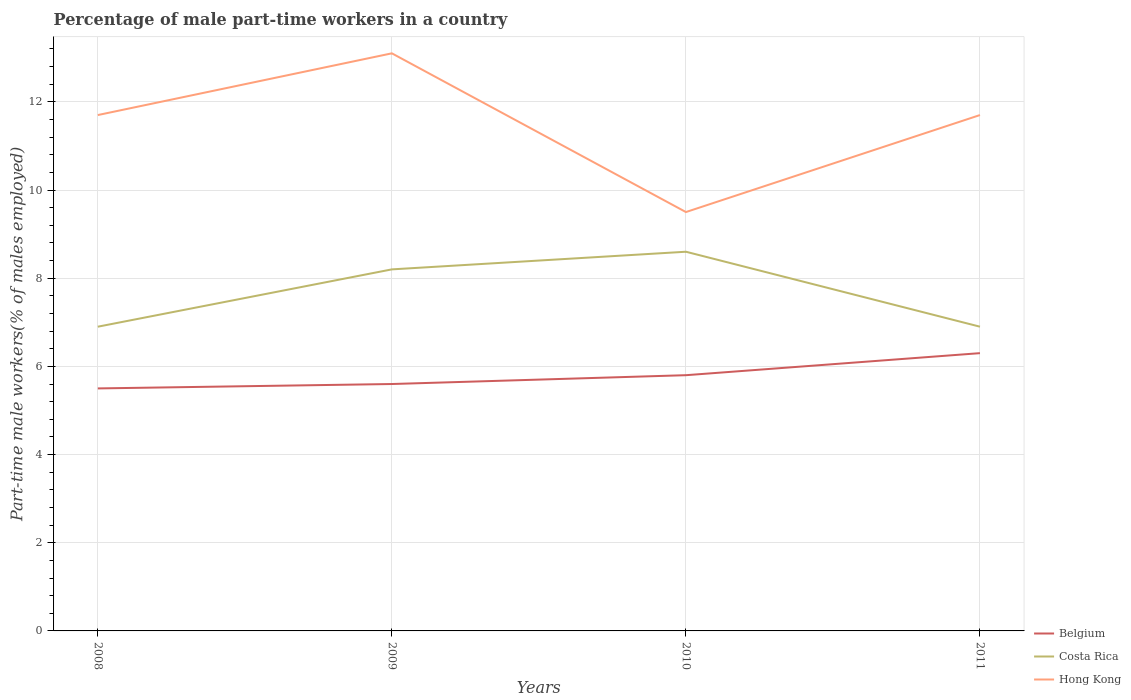How many different coloured lines are there?
Keep it short and to the point. 3. Across all years, what is the maximum percentage of male part-time workers in Hong Kong?
Give a very brief answer. 9.5. What is the total percentage of male part-time workers in Costa Rica in the graph?
Provide a succinct answer. -1.3. What is the difference between the highest and the second highest percentage of male part-time workers in Belgium?
Offer a terse response. 0.8. What is the difference between the highest and the lowest percentage of male part-time workers in Costa Rica?
Make the answer very short. 2. How many lines are there?
Keep it short and to the point. 3. Are the values on the major ticks of Y-axis written in scientific E-notation?
Provide a succinct answer. No. Where does the legend appear in the graph?
Your answer should be very brief. Bottom right. What is the title of the graph?
Your answer should be compact. Percentage of male part-time workers in a country. What is the label or title of the X-axis?
Your answer should be compact. Years. What is the label or title of the Y-axis?
Keep it short and to the point. Part-time male workers(% of males employed). What is the Part-time male workers(% of males employed) of Belgium in 2008?
Give a very brief answer. 5.5. What is the Part-time male workers(% of males employed) in Costa Rica in 2008?
Give a very brief answer. 6.9. What is the Part-time male workers(% of males employed) in Hong Kong in 2008?
Provide a short and direct response. 11.7. What is the Part-time male workers(% of males employed) of Belgium in 2009?
Provide a succinct answer. 5.6. What is the Part-time male workers(% of males employed) in Costa Rica in 2009?
Give a very brief answer. 8.2. What is the Part-time male workers(% of males employed) of Hong Kong in 2009?
Ensure brevity in your answer.  13.1. What is the Part-time male workers(% of males employed) in Belgium in 2010?
Your answer should be very brief. 5.8. What is the Part-time male workers(% of males employed) in Costa Rica in 2010?
Offer a very short reply. 8.6. What is the Part-time male workers(% of males employed) in Hong Kong in 2010?
Ensure brevity in your answer.  9.5. What is the Part-time male workers(% of males employed) of Belgium in 2011?
Make the answer very short. 6.3. What is the Part-time male workers(% of males employed) of Costa Rica in 2011?
Ensure brevity in your answer.  6.9. What is the Part-time male workers(% of males employed) of Hong Kong in 2011?
Your answer should be compact. 11.7. Across all years, what is the maximum Part-time male workers(% of males employed) of Belgium?
Offer a terse response. 6.3. Across all years, what is the maximum Part-time male workers(% of males employed) in Costa Rica?
Provide a succinct answer. 8.6. Across all years, what is the maximum Part-time male workers(% of males employed) in Hong Kong?
Your answer should be very brief. 13.1. Across all years, what is the minimum Part-time male workers(% of males employed) in Belgium?
Your answer should be very brief. 5.5. Across all years, what is the minimum Part-time male workers(% of males employed) of Costa Rica?
Offer a terse response. 6.9. Across all years, what is the minimum Part-time male workers(% of males employed) of Hong Kong?
Provide a short and direct response. 9.5. What is the total Part-time male workers(% of males employed) in Belgium in the graph?
Your response must be concise. 23.2. What is the total Part-time male workers(% of males employed) in Costa Rica in the graph?
Ensure brevity in your answer.  30.6. What is the total Part-time male workers(% of males employed) of Hong Kong in the graph?
Ensure brevity in your answer.  46. What is the difference between the Part-time male workers(% of males employed) in Costa Rica in 2008 and that in 2010?
Give a very brief answer. -1.7. What is the difference between the Part-time male workers(% of males employed) of Hong Kong in 2008 and that in 2010?
Offer a very short reply. 2.2. What is the difference between the Part-time male workers(% of males employed) in Belgium in 2008 and that in 2011?
Your answer should be very brief. -0.8. What is the difference between the Part-time male workers(% of males employed) in Costa Rica in 2008 and that in 2011?
Offer a very short reply. 0. What is the difference between the Part-time male workers(% of males employed) in Hong Kong in 2008 and that in 2011?
Ensure brevity in your answer.  0. What is the difference between the Part-time male workers(% of males employed) in Costa Rica in 2009 and that in 2010?
Keep it short and to the point. -0.4. What is the difference between the Part-time male workers(% of males employed) of Hong Kong in 2009 and that in 2010?
Provide a short and direct response. 3.6. What is the difference between the Part-time male workers(% of males employed) of Belgium in 2009 and that in 2011?
Your response must be concise. -0.7. What is the difference between the Part-time male workers(% of males employed) of Costa Rica in 2009 and that in 2011?
Offer a terse response. 1.3. What is the difference between the Part-time male workers(% of males employed) in Hong Kong in 2009 and that in 2011?
Make the answer very short. 1.4. What is the difference between the Part-time male workers(% of males employed) in Costa Rica in 2010 and that in 2011?
Make the answer very short. 1.7. What is the difference between the Part-time male workers(% of males employed) in Hong Kong in 2010 and that in 2011?
Provide a short and direct response. -2.2. What is the difference between the Part-time male workers(% of males employed) in Belgium in 2008 and the Part-time male workers(% of males employed) in Costa Rica in 2010?
Ensure brevity in your answer.  -3.1. What is the difference between the Part-time male workers(% of males employed) of Belgium in 2008 and the Part-time male workers(% of males employed) of Hong Kong in 2010?
Give a very brief answer. -4. What is the difference between the Part-time male workers(% of males employed) of Costa Rica in 2008 and the Part-time male workers(% of males employed) of Hong Kong in 2011?
Offer a terse response. -4.8. What is the difference between the Part-time male workers(% of males employed) in Costa Rica in 2009 and the Part-time male workers(% of males employed) in Hong Kong in 2010?
Make the answer very short. -1.3. What is the difference between the Part-time male workers(% of males employed) of Belgium in 2009 and the Part-time male workers(% of males employed) of Costa Rica in 2011?
Your answer should be very brief. -1.3. What is the difference between the Part-time male workers(% of males employed) in Belgium in 2009 and the Part-time male workers(% of males employed) in Hong Kong in 2011?
Offer a terse response. -6.1. What is the difference between the Part-time male workers(% of males employed) of Costa Rica in 2009 and the Part-time male workers(% of males employed) of Hong Kong in 2011?
Provide a short and direct response. -3.5. What is the difference between the Part-time male workers(% of males employed) of Belgium in 2010 and the Part-time male workers(% of males employed) of Hong Kong in 2011?
Give a very brief answer. -5.9. What is the difference between the Part-time male workers(% of males employed) in Costa Rica in 2010 and the Part-time male workers(% of males employed) in Hong Kong in 2011?
Give a very brief answer. -3.1. What is the average Part-time male workers(% of males employed) in Costa Rica per year?
Make the answer very short. 7.65. In the year 2009, what is the difference between the Part-time male workers(% of males employed) of Costa Rica and Part-time male workers(% of males employed) of Hong Kong?
Offer a terse response. -4.9. In the year 2010, what is the difference between the Part-time male workers(% of males employed) in Belgium and Part-time male workers(% of males employed) in Costa Rica?
Provide a succinct answer. -2.8. In the year 2011, what is the difference between the Part-time male workers(% of males employed) of Belgium and Part-time male workers(% of males employed) of Costa Rica?
Give a very brief answer. -0.6. In the year 2011, what is the difference between the Part-time male workers(% of males employed) of Belgium and Part-time male workers(% of males employed) of Hong Kong?
Ensure brevity in your answer.  -5.4. What is the ratio of the Part-time male workers(% of males employed) of Belgium in 2008 to that in 2009?
Make the answer very short. 0.98. What is the ratio of the Part-time male workers(% of males employed) of Costa Rica in 2008 to that in 2009?
Give a very brief answer. 0.84. What is the ratio of the Part-time male workers(% of males employed) of Hong Kong in 2008 to that in 2009?
Offer a very short reply. 0.89. What is the ratio of the Part-time male workers(% of males employed) in Belgium in 2008 to that in 2010?
Your answer should be compact. 0.95. What is the ratio of the Part-time male workers(% of males employed) of Costa Rica in 2008 to that in 2010?
Ensure brevity in your answer.  0.8. What is the ratio of the Part-time male workers(% of males employed) of Hong Kong in 2008 to that in 2010?
Give a very brief answer. 1.23. What is the ratio of the Part-time male workers(% of males employed) in Belgium in 2008 to that in 2011?
Make the answer very short. 0.87. What is the ratio of the Part-time male workers(% of males employed) of Hong Kong in 2008 to that in 2011?
Provide a succinct answer. 1. What is the ratio of the Part-time male workers(% of males employed) of Belgium in 2009 to that in 2010?
Provide a short and direct response. 0.97. What is the ratio of the Part-time male workers(% of males employed) of Costa Rica in 2009 to that in 2010?
Ensure brevity in your answer.  0.95. What is the ratio of the Part-time male workers(% of males employed) of Hong Kong in 2009 to that in 2010?
Give a very brief answer. 1.38. What is the ratio of the Part-time male workers(% of males employed) in Costa Rica in 2009 to that in 2011?
Offer a very short reply. 1.19. What is the ratio of the Part-time male workers(% of males employed) in Hong Kong in 2009 to that in 2011?
Offer a terse response. 1.12. What is the ratio of the Part-time male workers(% of males employed) in Belgium in 2010 to that in 2011?
Make the answer very short. 0.92. What is the ratio of the Part-time male workers(% of males employed) of Costa Rica in 2010 to that in 2011?
Provide a short and direct response. 1.25. What is the ratio of the Part-time male workers(% of males employed) in Hong Kong in 2010 to that in 2011?
Ensure brevity in your answer.  0.81. What is the difference between the highest and the second highest Part-time male workers(% of males employed) in Belgium?
Give a very brief answer. 0.5. What is the difference between the highest and the second highest Part-time male workers(% of males employed) in Costa Rica?
Offer a very short reply. 0.4. What is the difference between the highest and the second highest Part-time male workers(% of males employed) of Hong Kong?
Your response must be concise. 1.4. What is the difference between the highest and the lowest Part-time male workers(% of males employed) in Belgium?
Give a very brief answer. 0.8. 